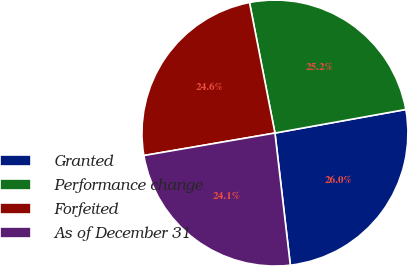Convert chart to OTSL. <chart><loc_0><loc_0><loc_500><loc_500><pie_chart><fcel>Granted<fcel>Performance change<fcel>Forfeited<fcel>As of December 31<nl><fcel>25.99%<fcel>25.23%<fcel>24.64%<fcel>24.14%<nl></chart> 